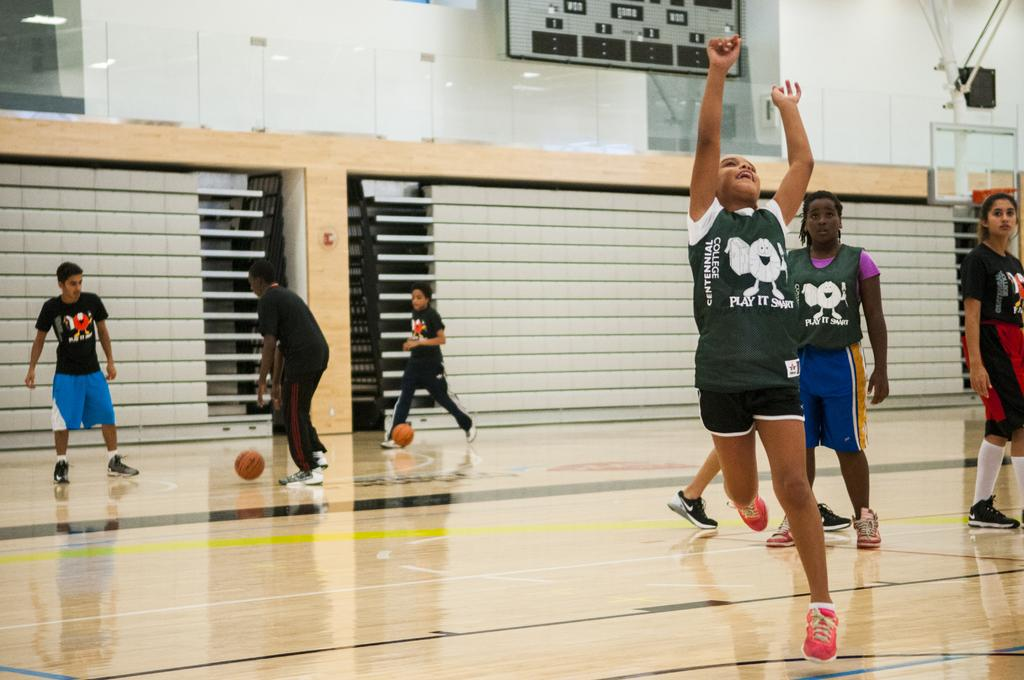What objects can be seen in the image? There are balls in the image. Who or what else is present in the image? There are people in the image. What is the color of the wall in the image? There is a white color wall in the image. What type of art is being created by the muscles in the image? There is no art or muscles present in the image; it features balls and people near a white wall. 